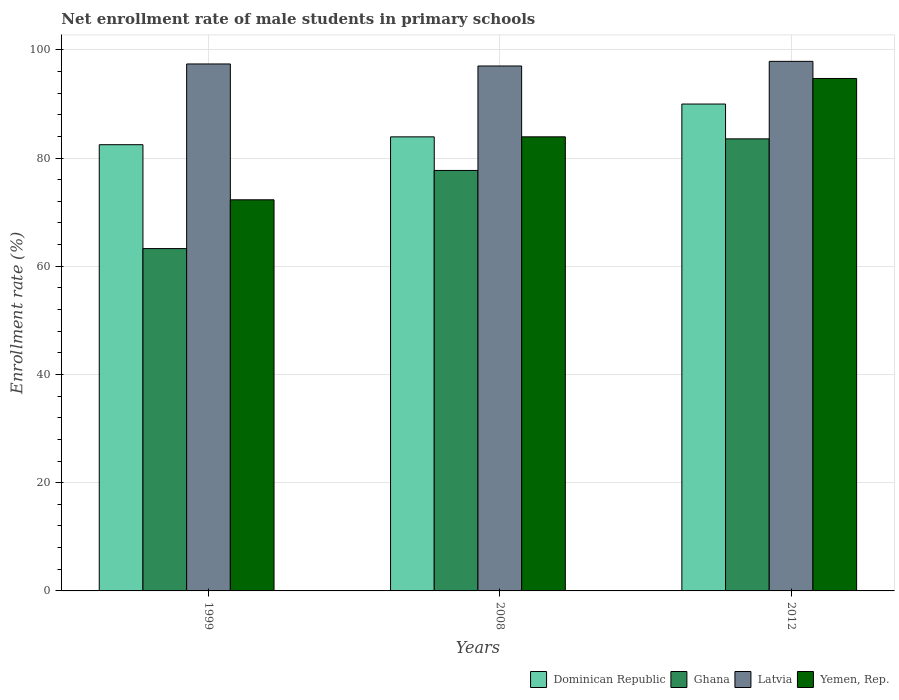How many groups of bars are there?
Provide a short and direct response. 3. Are the number of bars per tick equal to the number of legend labels?
Your answer should be very brief. Yes. How many bars are there on the 3rd tick from the left?
Provide a succinct answer. 4. What is the net enrollment rate of male students in primary schools in Ghana in 2008?
Offer a terse response. 77.7. Across all years, what is the maximum net enrollment rate of male students in primary schools in Yemen, Rep.?
Your response must be concise. 94.7. Across all years, what is the minimum net enrollment rate of male students in primary schools in Ghana?
Ensure brevity in your answer.  63.26. In which year was the net enrollment rate of male students in primary schools in Latvia maximum?
Offer a terse response. 2012. What is the total net enrollment rate of male students in primary schools in Latvia in the graph?
Make the answer very short. 292.25. What is the difference between the net enrollment rate of male students in primary schools in Latvia in 1999 and that in 2008?
Ensure brevity in your answer.  0.38. What is the difference between the net enrollment rate of male students in primary schools in Dominican Republic in 2008 and the net enrollment rate of male students in primary schools in Yemen, Rep. in 2012?
Make the answer very short. -10.79. What is the average net enrollment rate of male students in primary schools in Yemen, Rep. per year?
Your answer should be compact. 83.63. In the year 1999, what is the difference between the net enrollment rate of male students in primary schools in Dominican Republic and net enrollment rate of male students in primary schools in Latvia?
Provide a succinct answer. -14.92. What is the ratio of the net enrollment rate of male students in primary schools in Ghana in 2008 to that in 2012?
Provide a succinct answer. 0.93. What is the difference between the highest and the second highest net enrollment rate of male students in primary schools in Yemen, Rep.?
Provide a succinct answer. 10.78. What is the difference between the highest and the lowest net enrollment rate of male students in primary schools in Ghana?
Offer a terse response. 20.28. In how many years, is the net enrollment rate of male students in primary schools in Latvia greater than the average net enrollment rate of male students in primary schools in Latvia taken over all years?
Your answer should be compact. 1. Is the sum of the net enrollment rate of male students in primary schools in Ghana in 2008 and 2012 greater than the maximum net enrollment rate of male students in primary schools in Latvia across all years?
Provide a short and direct response. Yes. Is it the case that in every year, the sum of the net enrollment rate of male students in primary schools in Yemen, Rep. and net enrollment rate of male students in primary schools in Ghana is greater than the sum of net enrollment rate of male students in primary schools in Dominican Republic and net enrollment rate of male students in primary schools in Latvia?
Keep it short and to the point. No. What does the 2nd bar from the left in 2012 represents?
Offer a very short reply. Ghana. What does the 2nd bar from the right in 2008 represents?
Your response must be concise. Latvia. How many years are there in the graph?
Your response must be concise. 3. What is the title of the graph?
Keep it short and to the point. Net enrollment rate of male students in primary schools. Does "Slovenia" appear as one of the legend labels in the graph?
Your answer should be very brief. No. What is the label or title of the X-axis?
Your answer should be very brief. Years. What is the label or title of the Y-axis?
Offer a terse response. Enrollment rate (%). What is the Enrollment rate (%) in Dominican Republic in 1999?
Provide a succinct answer. 82.46. What is the Enrollment rate (%) in Ghana in 1999?
Provide a succinct answer. 63.26. What is the Enrollment rate (%) of Latvia in 1999?
Provide a succinct answer. 97.38. What is the Enrollment rate (%) in Yemen, Rep. in 1999?
Your answer should be compact. 72.28. What is the Enrollment rate (%) in Dominican Republic in 2008?
Your response must be concise. 83.91. What is the Enrollment rate (%) in Ghana in 2008?
Provide a short and direct response. 77.7. What is the Enrollment rate (%) in Latvia in 2008?
Offer a very short reply. 97. What is the Enrollment rate (%) of Yemen, Rep. in 2008?
Provide a succinct answer. 83.92. What is the Enrollment rate (%) of Dominican Republic in 2012?
Give a very brief answer. 89.97. What is the Enrollment rate (%) in Ghana in 2012?
Provide a succinct answer. 83.54. What is the Enrollment rate (%) in Latvia in 2012?
Offer a very short reply. 97.86. What is the Enrollment rate (%) of Yemen, Rep. in 2012?
Your answer should be compact. 94.7. Across all years, what is the maximum Enrollment rate (%) of Dominican Republic?
Offer a very short reply. 89.97. Across all years, what is the maximum Enrollment rate (%) in Ghana?
Offer a very short reply. 83.54. Across all years, what is the maximum Enrollment rate (%) in Latvia?
Offer a very short reply. 97.86. Across all years, what is the maximum Enrollment rate (%) in Yemen, Rep.?
Give a very brief answer. 94.7. Across all years, what is the minimum Enrollment rate (%) of Dominican Republic?
Offer a terse response. 82.46. Across all years, what is the minimum Enrollment rate (%) in Ghana?
Offer a very short reply. 63.26. Across all years, what is the minimum Enrollment rate (%) in Latvia?
Ensure brevity in your answer.  97. Across all years, what is the minimum Enrollment rate (%) of Yemen, Rep.?
Provide a short and direct response. 72.28. What is the total Enrollment rate (%) of Dominican Republic in the graph?
Provide a succinct answer. 256.35. What is the total Enrollment rate (%) in Ghana in the graph?
Your answer should be compact. 224.51. What is the total Enrollment rate (%) in Latvia in the graph?
Your response must be concise. 292.25. What is the total Enrollment rate (%) in Yemen, Rep. in the graph?
Make the answer very short. 250.89. What is the difference between the Enrollment rate (%) of Dominican Republic in 1999 and that in 2008?
Provide a short and direct response. -1.45. What is the difference between the Enrollment rate (%) of Ghana in 1999 and that in 2008?
Offer a terse response. -14.44. What is the difference between the Enrollment rate (%) of Latvia in 1999 and that in 2008?
Your answer should be compact. 0.38. What is the difference between the Enrollment rate (%) of Yemen, Rep. in 1999 and that in 2008?
Ensure brevity in your answer.  -11.64. What is the difference between the Enrollment rate (%) in Dominican Republic in 1999 and that in 2012?
Your answer should be very brief. -7.51. What is the difference between the Enrollment rate (%) in Ghana in 1999 and that in 2012?
Your answer should be compact. -20.28. What is the difference between the Enrollment rate (%) of Latvia in 1999 and that in 2012?
Your response must be concise. -0.48. What is the difference between the Enrollment rate (%) in Yemen, Rep. in 1999 and that in 2012?
Offer a terse response. -22.42. What is the difference between the Enrollment rate (%) in Dominican Republic in 2008 and that in 2012?
Provide a short and direct response. -6.06. What is the difference between the Enrollment rate (%) of Ghana in 2008 and that in 2012?
Give a very brief answer. -5.84. What is the difference between the Enrollment rate (%) in Latvia in 2008 and that in 2012?
Your answer should be compact. -0.86. What is the difference between the Enrollment rate (%) of Yemen, Rep. in 2008 and that in 2012?
Give a very brief answer. -10.78. What is the difference between the Enrollment rate (%) of Dominican Republic in 1999 and the Enrollment rate (%) of Ghana in 2008?
Your answer should be compact. 4.76. What is the difference between the Enrollment rate (%) in Dominican Republic in 1999 and the Enrollment rate (%) in Latvia in 2008?
Your answer should be compact. -14.54. What is the difference between the Enrollment rate (%) of Dominican Republic in 1999 and the Enrollment rate (%) of Yemen, Rep. in 2008?
Provide a succinct answer. -1.45. What is the difference between the Enrollment rate (%) of Ghana in 1999 and the Enrollment rate (%) of Latvia in 2008?
Your response must be concise. -33.74. What is the difference between the Enrollment rate (%) of Ghana in 1999 and the Enrollment rate (%) of Yemen, Rep. in 2008?
Give a very brief answer. -20.65. What is the difference between the Enrollment rate (%) of Latvia in 1999 and the Enrollment rate (%) of Yemen, Rep. in 2008?
Provide a succinct answer. 13.47. What is the difference between the Enrollment rate (%) of Dominican Republic in 1999 and the Enrollment rate (%) of Ghana in 2012?
Make the answer very short. -1.08. What is the difference between the Enrollment rate (%) of Dominican Republic in 1999 and the Enrollment rate (%) of Latvia in 2012?
Your answer should be very brief. -15.4. What is the difference between the Enrollment rate (%) in Dominican Republic in 1999 and the Enrollment rate (%) in Yemen, Rep. in 2012?
Give a very brief answer. -12.24. What is the difference between the Enrollment rate (%) in Ghana in 1999 and the Enrollment rate (%) in Latvia in 2012?
Provide a succinct answer. -34.6. What is the difference between the Enrollment rate (%) of Ghana in 1999 and the Enrollment rate (%) of Yemen, Rep. in 2012?
Your answer should be compact. -31.44. What is the difference between the Enrollment rate (%) of Latvia in 1999 and the Enrollment rate (%) of Yemen, Rep. in 2012?
Provide a short and direct response. 2.68. What is the difference between the Enrollment rate (%) of Dominican Republic in 2008 and the Enrollment rate (%) of Ghana in 2012?
Give a very brief answer. 0.37. What is the difference between the Enrollment rate (%) in Dominican Republic in 2008 and the Enrollment rate (%) in Latvia in 2012?
Keep it short and to the point. -13.95. What is the difference between the Enrollment rate (%) of Dominican Republic in 2008 and the Enrollment rate (%) of Yemen, Rep. in 2012?
Offer a terse response. -10.79. What is the difference between the Enrollment rate (%) of Ghana in 2008 and the Enrollment rate (%) of Latvia in 2012?
Give a very brief answer. -20.16. What is the difference between the Enrollment rate (%) in Ghana in 2008 and the Enrollment rate (%) in Yemen, Rep. in 2012?
Your response must be concise. -17. What is the difference between the Enrollment rate (%) of Latvia in 2008 and the Enrollment rate (%) of Yemen, Rep. in 2012?
Provide a succinct answer. 2.31. What is the average Enrollment rate (%) in Dominican Republic per year?
Make the answer very short. 85.45. What is the average Enrollment rate (%) in Ghana per year?
Make the answer very short. 74.84. What is the average Enrollment rate (%) in Latvia per year?
Provide a short and direct response. 97.42. What is the average Enrollment rate (%) in Yemen, Rep. per year?
Make the answer very short. 83.63. In the year 1999, what is the difference between the Enrollment rate (%) of Dominican Republic and Enrollment rate (%) of Ghana?
Offer a terse response. 19.2. In the year 1999, what is the difference between the Enrollment rate (%) of Dominican Republic and Enrollment rate (%) of Latvia?
Your answer should be very brief. -14.92. In the year 1999, what is the difference between the Enrollment rate (%) of Dominican Republic and Enrollment rate (%) of Yemen, Rep.?
Ensure brevity in your answer.  10.18. In the year 1999, what is the difference between the Enrollment rate (%) of Ghana and Enrollment rate (%) of Latvia?
Your answer should be very brief. -34.12. In the year 1999, what is the difference between the Enrollment rate (%) in Ghana and Enrollment rate (%) in Yemen, Rep.?
Provide a short and direct response. -9.01. In the year 1999, what is the difference between the Enrollment rate (%) in Latvia and Enrollment rate (%) in Yemen, Rep.?
Provide a short and direct response. 25.1. In the year 2008, what is the difference between the Enrollment rate (%) in Dominican Republic and Enrollment rate (%) in Ghana?
Your answer should be very brief. 6.21. In the year 2008, what is the difference between the Enrollment rate (%) in Dominican Republic and Enrollment rate (%) in Latvia?
Offer a terse response. -13.09. In the year 2008, what is the difference between the Enrollment rate (%) of Dominican Republic and Enrollment rate (%) of Yemen, Rep.?
Offer a very short reply. -0. In the year 2008, what is the difference between the Enrollment rate (%) of Ghana and Enrollment rate (%) of Latvia?
Give a very brief answer. -19.3. In the year 2008, what is the difference between the Enrollment rate (%) in Ghana and Enrollment rate (%) in Yemen, Rep.?
Keep it short and to the point. -6.21. In the year 2008, what is the difference between the Enrollment rate (%) in Latvia and Enrollment rate (%) in Yemen, Rep.?
Ensure brevity in your answer.  13.09. In the year 2012, what is the difference between the Enrollment rate (%) in Dominican Republic and Enrollment rate (%) in Ghana?
Offer a terse response. 6.43. In the year 2012, what is the difference between the Enrollment rate (%) of Dominican Republic and Enrollment rate (%) of Latvia?
Make the answer very short. -7.89. In the year 2012, what is the difference between the Enrollment rate (%) in Dominican Republic and Enrollment rate (%) in Yemen, Rep.?
Your answer should be compact. -4.72. In the year 2012, what is the difference between the Enrollment rate (%) in Ghana and Enrollment rate (%) in Latvia?
Offer a very short reply. -14.32. In the year 2012, what is the difference between the Enrollment rate (%) in Ghana and Enrollment rate (%) in Yemen, Rep.?
Provide a short and direct response. -11.16. In the year 2012, what is the difference between the Enrollment rate (%) in Latvia and Enrollment rate (%) in Yemen, Rep.?
Provide a short and direct response. 3.16. What is the ratio of the Enrollment rate (%) in Dominican Republic in 1999 to that in 2008?
Offer a very short reply. 0.98. What is the ratio of the Enrollment rate (%) in Ghana in 1999 to that in 2008?
Offer a very short reply. 0.81. What is the ratio of the Enrollment rate (%) in Yemen, Rep. in 1999 to that in 2008?
Your response must be concise. 0.86. What is the ratio of the Enrollment rate (%) in Dominican Republic in 1999 to that in 2012?
Provide a succinct answer. 0.92. What is the ratio of the Enrollment rate (%) of Ghana in 1999 to that in 2012?
Provide a succinct answer. 0.76. What is the ratio of the Enrollment rate (%) of Latvia in 1999 to that in 2012?
Make the answer very short. 1. What is the ratio of the Enrollment rate (%) of Yemen, Rep. in 1999 to that in 2012?
Ensure brevity in your answer.  0.76. What is the ratio of the Enrollment rate (%) of Dominican Republic in 2008 to that in 2012?
Keep it short and to the point. 0.93. What is the ratio of the Enrollment rate (%) of Ghana in 2008 to that in 2012?
Offer a very short reply. 0.93. What is the ratio of the Enrollment rate (%) of Yemen, Rep. in 2008 to that in 2012?
Give a very brief answer. 0.89. What is the difference between the highest and the second highest Enrollment rate (%) in Dominican Republic?
Your answer should be very brief. 6.06. What is the difference between the highest and the second highest Enrollment rate (%) of Ghana?
Provide a short and direct response. 5.84. What is the difference between the highest and the second highest Enrollment rate (%) in Latvia?
Your answer should be very brief. 0.48. What is the difference between the highest and the second highest Enrollment rate (%) of Yemen, Rep.?
Provide a succinct answer. 10.78. What is the difference between the highest and the lowest Enrollment rate (%) in Dominican Republic?
Your answer should be very brief. 7.51. What is the difference between the highest and the lowest Enrollment rate (%) of Ghana?
Your answer should be compact. 20.28. What is the difference between the highest and the lowest Enrollment rate (%) of Latvia?
Make the answer very short. 0.86. What is the difference between the highest and the lowest Enrollment rate (%) of Yemen, Rep.?
Make the answer very short. 22.42. 